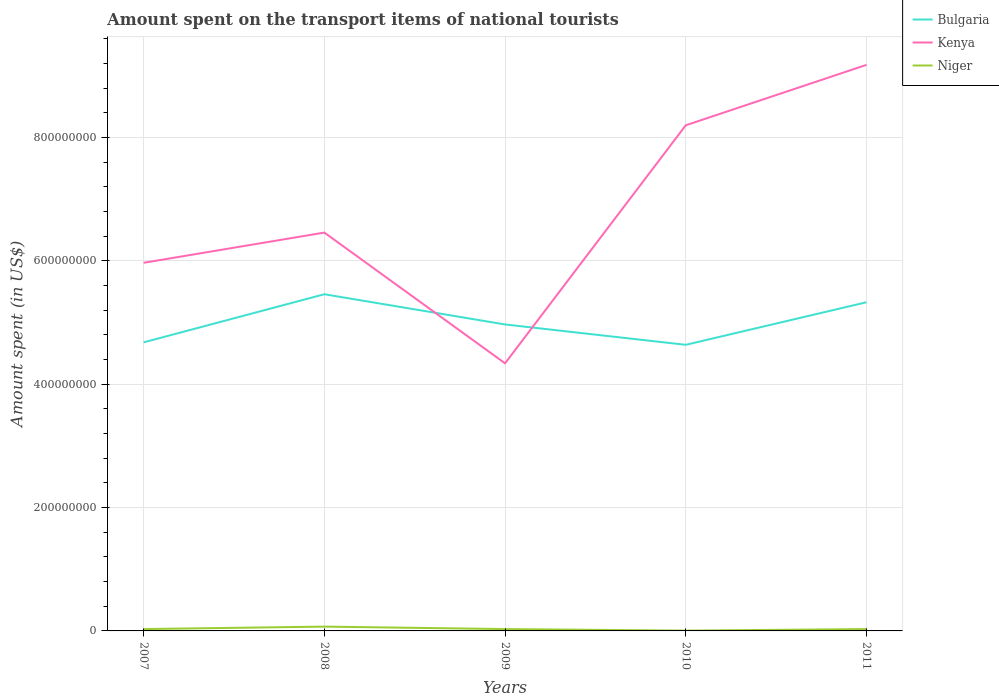Does the line corresponding to Kenya intersect with the line corresponding to Bulgaria?
Offer a terse response. Yes. Across all years, what is the maximum amount spent on the transport items of national tourists in Bulgaria?
Offer a terse response. 4.64e+08. What is the total amount spent on the transport items of national tourists in Niger in the graph?
Your answer should be very brief. 2.50e+06. What is the difference between the highest and the second highest amount spent on the transport items of national tourists in Kenya?
Provide a short and direct response. 4.84e+08. What is the difference between the highest and the lowest amount spent on the transport items of national tourists in Niger?
Offer a terse response. 1. Is the amount spent on the transport items of national tourists in Kenya strictly greater than the amount spent on the transport items of national tourists in Niger over the years?
Make the answer very short. No. Are the values on the major ticks of Y-axis written in scientific E-notation?
Offer a terse response. No. Does the graph contain grids?
Your answer should be very brief. Yes. How many legend labels are there?
Offer a terse response. 3. How are the legend labels stacked?
Give a very brief answer. Vertical. What is the title of the graph?
Make the answer very short. Amount spent on the transport items of national tourists. What is the label or title of the X-axis?
Your answer should be very brief. Years. What is the label or title of the Y-axis?
Give a very brief answer. Amount spent (in US$). What is the Amount spent (in US$) of Bulgaria in 2007?
Your response must be concise. 4.68e+08. What is the Amount spent (in US$) of Kenya in 2007?
Provide a succinct answer. 5.97e+08. What is the Amount spent (in US$) of Bulgaria in 2008?
Provide a succinct answer. 5.46e+08. What is the Amount spent (in US$) of Kenya in 2008?
Provide a short and direct response. 6.46e+08. What is the Amount spent (in US$) in Niger in 2008?
Provide a succinct answer. 7.00e+06. What is the Amount spent (in US$) in Bulgaria in 2009?
Keep it short and to the point. 4.97e+08. What is the Amount spent (in US$) in Kenya in 2009?
Keep it short and to the point. 4.34e+08. What is the Amount spent (in US$) of Niger in 2009?
Offer a very short reply. 3.00e+06. What is the Amount spent (in US$) in Bulgaria in 2010?
Provide a short and direct response. 4.64e+08. What is the Amount spent (in US$) of Kenya in 2010?
Your answer should be very brief. 8.20e+08. What is the Amount spent (in US$) of Niger in 2010?
Your response must be concise. 5.00e+05. What is the Amount spent (in US$) in Bulgaria in 2011?
Ensure brevity in your answer.  5.33e+08. What is the Amount spent (in US$) of Kenya in 2011?
Make the answer very short. 9.18e+08. What is the Amount spent (in US$) in Niger in 2011?
Keep it short and to the point. 3.00e+06. Across all years, what is the maximum Amount spent (in US$) of Bulgaria?
Provide a short and direct response. 5.46e+08. Across all years, what is the maximum Amount spent (in US$) in Kenya?
Provide a succinct answer. 9.18e+08. Across all years, what is the minimum Amount spent (in US$) in Bulgaria?
Offer a very short reply. 4.64e+08. Across all years, what is the minimum Amount spent (in US$) in Kenya?
Offer a very short reply. 4.34e+08. Across all years, what is the minimum Amount spent (in US$) of Niger?
Make the answer very short. 5.00e+05. What is the total Amount spent (in US$) in Bulgaria in the graph?
Your answer should be very brief. 2.51e+09. What is the total Amount spent (in US$) of Kenya in the graph?
Provide a succinct answer. 3.42e+09. What is the total Amount spent (in US$) of Niger in the graph?
Offer a terse response. 1.65e+07. What is the difference between the Amount spent (in US$) in Bulgaria in 2007 and that in 2008?
Your answer should be compact. -7.80e+07. What is the difference between the Amount spent (in US$) of Kenya in 2007 and that in 2008?
Ensure brevity in your answer.  -4.90e+07. What is the difference between the Amount spent (in US$) in Niger in 2007 and that in 2008?
Offer a terse response. -4.00e+06. What is the difference between the Amount spent (in US$) in Bulgaria in 2007 and that in 2009?
Give a very brief answer. -2.90e+07. What is the difference between the Amount spent (in US$) in Kenya in 2007 and that in 2009?
Provide a short and direct response. 1.63e+08. What is the difference between the Amount spent (in US$) of Kenya in 2007 and that in 2010?
Your answer should be very brief. -2.23e+08. What is the difference between the Amount spent (in US$) in Niger in 2007 and that in 2010?
Your answer should be very brief. 2.50e+06. What is the difference between the Amount spent (in US$) in Bulgaria in 2007 and that in 2011?
Provide a short and direct response. -6.50e+07. What is the difference between the Amount spent (in US$) in Kenya in 2007 and that in 2011?
Your answer should be compact. -3.21e+08. What is the difference between the Amount spent (in US$) of Niger in 2007 and that in 2011?
Ensure brevity in your answer.  0. What is the difference between the Amount spent (in US$) in Bulgaria in 2008 and that in 2009?
Give a very brief answer. 4.90e+07. What is the difference between the Amount spent (in US$) in Kenya in 2008 and that in 2009?
Provide a succinct answer. 2.12e+08. What is the difference between the Amount spent (in US$) of Niger in 2008 and that in 2009?
Offer a terse response. 4.00e+06. What is the difference between the Amount spent (in US$) in Bulgaria in 2008 and that in 2010?
Provide a succinct answer. 8.20e+07. What is the difference between the Amount spent (in US$) in Kenya in 2008 and that in 2010?
Your answer should be very brief. -1.74e+08. What is the difference between the Amount spent (in US$) in Niger in 2008 and that in 2010?
Your answer should be very brief. 6.50e+06. What is the difference between the Amount spent (in US$) in Bulgaria in 2008 and that in 2011?
Offer a terse response. 1.30e+07. What is the difference between the Amount spent (in US$) in Kenya in 2008 and that in 2011?
Ensure brevity in your answer.  -2.72e+08. What is the difference between the Amount spent (in US$) in Niger in 2008 and that in 2011?
Ensure brevity in your answer.  4.00e+06. What is the difference between the Amount spent (in US$) of Bulgaria in 2009 and that in 2010?
Give a very brief answer. 3.30e+07. What is the difference between the Amount spent (in US$) in Kenya in 2009 and that in 2010?
Offer a very short reply. -3.86e+08. What is the difference between the Amount spent (in US$) in Niger in 2009 and that in 2010?
Offer a terse response. 2.50e+06. What is the difference between the Amount spent (in US$) of Bulgaria in 2009 and that in 2011?
Give a very brief answer. -3.60e+07. What is the difference between the Amount spent (in US$) in Kenya in 2009 and that in 2011?
Your answer should be very brief. -4.84e+08. What is the difference between the Amount spent (in US$) in Bulgaria in 2010 and that in 2011?
Keep it short and to the point. -6.90e+07. What is the difference between the Amount spent (in US$) of Kenya in 2010 and that in 2011?
Offer a very short reply. -9.80e+07. What is the difference between the Amount spent (in US$) of Niger in 2010 and that in 2011?
Keep it short and to the point. -2.50e+06. What is the difference between the Amount spent (in US$) in Bulgaria in 2007 and the Amount spent (in US$) in Kenya in 2008?
Provide a succinct answer. -1.78e+08. What is the difference between the Amount spent (in US$) of Bulgaria in 2007 and the Amount spent (in US$) of Niger in 2008?
Give a very brief answer. 4.61e+08. What is the difference between the Amount spent (in US$) in Kenya in 2007 and the Amount spent (in US$) in Niger in 2008?
Your answer should be very brief. 5.90e+08. What is the difference between the Amount spent (in US$) in Bulgaria in 2007 and the Amount spent (in US$) in Kenya in 2009?
Provide a succinct answer. 3.40e+07. What is the difference between the Amount spent (in US$) of Bulgaria in 2007 and the Amount spent (in US$) of Niger in 2009?
Keep it short and to the point. 4.65e+08. What is the difference between the Amount spent (in US$) of Kenya in 2007 and the Amount spent (in US$) of Niger in 2009?
Keep it short and to the point. 5.94e+08. What is the difference between the Amount spent (in US$) of Bulgaria in 2007 and the Amount spent (in US$) of Kenya in 2010?
Offer a very short reply. -3.52e+08. What is the difference between the Amount spent (in US$) in Bulgaria in 2007 and the Amount spent (in US$) in Niger in 2010?
Give a very brief answer. 4.68e+08. What is the difference between the Amount spent (in US$) in Kenya in 2007 and the Amount spent (in US$) in Niger in 2010?
Ensure brevity in your answer.  5.96e+08. What is the difference between the Amount spent (in US$) in Bulgaria in 2007 and the Amount spent (in US$) in Kenya in 2011?
Your answer should be very brief. -4.50e+08. What is the difference between the Amount spent (in US$) in Bulgaria in 2007 and the Amount spent (in US$) in Niger in 2011?
Offer a very short reply. 4.65e+08. What is the difference between the Amount spent (in US$) of Kenya in 2007 and the Amount spent (in US$) of Niger in 2011?
Your answer should be compact. 5.94e+08. What is the difference between the Amount spent (in US$) in Bulgaria in 2008 and the Amount spent (in US$) in Kenya in 2009?
Give a very brief answer. 1.12e+08. What is the difference between the Amount spent (in US$) of Bulgaria in 2008 and the Amount spent (in US$) of Niger in 2009?
Make the answer very short. 5.43e+08. What is the difference between the Amount spent (in US$) in Kenya in 2008 and the Amount spent (in US$) in Niger in 2009?
Provide a short and direct response. 6.43e+08. What is the difference between the Amount spent (in US$) of Bulgaria in 2008 and the Amount spent (in US$) of Kenya in 2010?
Provide a succinct answer. -2.74e+08. What is the difference between the Amount spent (in US$) in Bulgaria in 2008 and the Amount spent (in US$) in Niger in 2010?
Keep it short and to the point. 5.46e+08. What is the difference between the Amount spent (in US$) in Kenya in 2008 and the Amount spent (in US$) in Niger in 2010?
Keep it short and to the point. 6.46e+08. What is the difference between the Amount spent (in US$) in Bulgaria in 2008 and the Amount spent (in US$) in Kenya in 2011?
Ensure brevity in your answer.  -3.72e+08. What is the difference between the Amount spent (in US$) of Bulgaria in 2008 and the Amount spent (in US$) of Niger in 2011?
Provide a short and direct response. 5.43e+08. What is the difference between the Amount spent (in US$) of Kenya in 2008 and the Amount spent (in US$) of Niger in 2011?
Your response must be concise. 6.43e+08. What is the difference between the Amount spent (in US$) in Bulgaria in 2009 and the Amount spent (in US$) in Kenya in 2010?
Provide a succinct answer. -3.23e+08. What is the difference between the Amount spent (in US$) in Bulgaria in 2009 and the Amount spent (in US$) in Niger in 2010?
Keep it short and to the point. 4.96e+08. What is the difference between the Amount spent (in US$) of Kenya in 2009 and the Amount spent (in US$) of Niger in 2010?
Ensure brevity in your answer.  4.34e+08. What is the difference between the Amount spent (in US$) in Bulgaria in 2009 and the Amount spent (in US$) in Kenya in 2011?
Ensure brevity in your answer.  -4.21e+08. What is the difference between the Amount spent (in US$) of Bulgaria in 2009 and the Amount spent (in US$) of Niger in 2011?
Keep it short and to the point. 4.94e+08. What is the difference between the Amount spent (in US$) in Kenya in 2009 and the Amount spent (in US$) in Niger in 2011?
Provide a short and direct response. 4.31e+08. What is the difference between the Amount spent (in US$) of Bulgaria in 2010 and the Amount spent (in US$) of Kenya in 2011?
Make the answer very short. -4.54e+08. What is the difference between the Amount spent (in US$) of Bulgaria in 2010 and the Amount spent (in US$) of Niger in 2011?
Keep it short and to the point. 4.61e+08. What is the difference between the Amount spent (in US$) in Kenya in 2010 and the Amount spent (in US$) in Niger in 2011?
Your response must be concise. 8.17e+08. What is the average Amount spent (in US$) in Bulgaria per year?
Give a very brief answer. 5.02e+08. What is the average Amount spent (in US$) in Kenya per year?
Offer a terse response. 6.83e+08. What is the average Amount spent (in US$) of Niger per year?
Make the answer very short. 3.30e+06. In the year 2007, what is the difference between the Amount spent (in US$) in Bulgaria and Amount spent (in US$) in Kenya?
Make the answer very short. -1.29e+08. In the year 2007, what is the difference between the Amount spent (in US$) in Bulgaria and Amount spent (in US$) in Niger?
Ensure brevity in your answer.  4.65e+08. In the year 2007, what is the difference between the Amount spent (in US$) of Kenya and Amount spent (in US$) of Niger?
Give a very brief answer. 5.94e+08. In the year 2008, what is the difference between the Amount spent (in US$) in Bulgaria and Amount spent (in US$) in Kenya?
Your answer should be compact. -1.00e+08. In the year 2008, what is the difference between the Amount spent (in US$) in Bulgaria and Amount spent (in US$) in Niger?
Your answer should be very brief. 5.39e+08. In the year 2008, what is the difference between the Amount spent (in US$) in Kenya and Amount spent (in US$) in Niger?
Your answer should be compact. 6.39e+08. In the year 2009, what is the difference between the Amount spent (in US$) in Bulgaria and Amount spent (in US$) in Kenya?
Ensure brevity in your answer.  6.30e+07. In the year 2009, what is the difference between the Amount spent (in US$) in Bulgaria and Amount spent (in US$) in Niger?
Ensure brevity in your answer.  4.94e+08. In the year 2009, what is the difference between the Amount spent (in US$) of Kenya and Amount spent (in US$) of Niger?
Provide a short and direct response. 4.31e+08. In the year 2010, what is the difference between the Amount spent (in US$) of Bulgaria and Amount spent (in US$) of Kenya?
Provide a succinct answer. -3.56e+08. In the year 2010, what is the difference between the Amount spent (in US$) in Bulgaria and Amount spent (in US$) in Niger?
Provide a succinct answer. 4.64e+08. In the year 2010, what is the difference between the Amount spent (in US$) in Kenya and Amount spent (in US$) in Niger?
Keep it short and to the point. 8.20e+08. In the year 2011, what is the difference between the Amount spent (in US$) of Bulgaria and Amount spent (in US$) of Kenya?
Ensure brevity in your answer.  -3.85e+08. In the year 2011, what is the difference between the Amount spent (in US$) in Bulgaria and Amount spent (in US$) in Niger?
Ensure brevity in your answer.  5.30e+08. In the year 2011, what is the difference between the Amount spent (in US$) of Kenya and Amount spent (in US$) of Niger?
Your answer should be very brief. 9.15e+08. What is the ratio of the Amount spent (in US$) of Bulgaria in 2007 to that in 2008?
Keep it short and to the point. 0.86. What is the ratio of the Amount spent (in US$) of Kenya in 2007 to that in 2008?
Offer a very short reply. 0.92. What is the ratio of the Amount spent (in US$) of Niger in 2007 to that in 2008?
Provide a short and direct response. 0.43. What is the ratio of the Amount spent (in US$) of Bulgaria in 2007 to that in 2009?
Your response must be concise. 0.94. What is the ratio of the Amount spent (in US$) of Kenya in 2007 to that in 2009?
Make the answer very short. 1.38. What is the ratio of the Amount spent (in US$) in Bulgaria in 2007 to that in 2010?
Ensure brevity in your answer.  1.01. What is the ratio of the Amount spent (in US$) in Kenya in 2007 to that in 2010?
Offer a terse response. 0.73. What is the ratio of the Amount spent (in US$) in Niger in 2007 to that in 2010?
Your answer should be very brief. 6. What is the ratio of the Amount spent (in US$) in Bulgaria in 2007 to that in 2011?
Your response must be concise. 0.88. What is the ratio of the Amount spent (in US$) of Kenya in 2007 to that in 2011?
Your answer should be compact. 0.65. What is the ratio of the Amount spent (in US$) in Niger in 2007 to that in 2011?
Provide a short and direct response. 1. What is the ratio of the Amount spent (in US$) of Bulgaria in 2008 to that in 2009?
Your response must be concise. 1.1. What is the ratio of the Amount spent (in US$) in Kenya in 2008 to that in 2009?
Your response must be concise. 1.49. What is the ratio of the Amount spent (in US$) of Niger in 2008 to that in 2009?
Your response must be concise. 2.33. What is the ratio of the Amount spent (in US$) of Bulgaria in 2008 to that in 2010?
Ensure brevity in your answer.  1.18. What is the ratio of the Amount spent (in US$) in Kenya in 2008 to that in 2010?
Make the answer very short. 0.79. What is the ratio of the Amount spent (in US$) in Niger in 2008 to that in 2010?
Your answer should be compact. 14. What is the ratio of the Amount spent (in US$) of Bulgaria in 2008 to that in 2011?
Give a very brief answer. 1.02. What is the ratio of the Amount spent (in US$) of Kenya in 2008 to that in 2011?
Give a very brief answer. 0.7. What is the ratio of the Amount spent (in US$) of Niger in 2008 to that in 2011?
Provide a short and direct response. 2.33. What is the ratio of the Amount spent (in US$) of Bulgaria in 2009 to that in 2010?
Provide a succinct answer. 1.07. What is the ratio of the Amount spent (in US$) in Kenya in 2009 to that in 2010?
Ensure brevity in your answer.  0.53. What is the ratio of the Amount spent (in US$) in Niger in 2009 to that in 2010?
Your response must be concise. 6. What is the ratio of the Amount spent (in US$) of Bulgaria in 2009 to that in 2011?
Offer a terse response. 0.93. What is the ratio of the Amount spent (in US$) of Kenya in 2009 to that in 2011?
Your answer should be compact. 0.47. What is the ratio of the Amount spent (in US$) in Niger in 2009 to that in 2011?
Give a very brief answer. 1. What is the ratio of the Amount spent (in US$) in Bulgaria in 2010 to that in 2011?
Provide a short and direct response. 0.87. What is the ratio of the Amount spent (in US$) of Kenya in 2010 to that in 2011?
Offer a terse response. 0.89. What is the difference between the highest and the second highest Amount spent (in US$) of Bulgaria?
Your answer should be compact. 1.30e+07. What is the difference between the highest and the second highest Amount spent (in US$) of Kenya?
Your response must be concise. 9.80e+07. What is the difference between the highest and the lowest Amount spent (in US$) of Bulgaria?
Offer a very short reply. 8.20e+07. What is the difference between the highest and the lowest Amount spent (in US$) of Kenya?
Make the answer very short. 4.84e+08. What is the difference between the highest and the lowest Amount spent (in US$) of Niger?
Keep it short and to the point. 6.50e+06. 